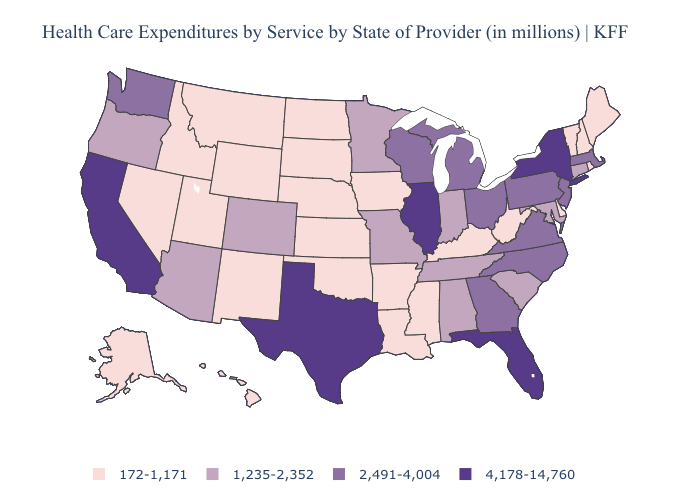Does Arizona have a lower value than Massachusetts?
Keep it brief. Yes. Name the states that have a value in the range 4,178-14,760?
Answer briefly. California, Florida, Illinois, New York, Texas. Name the states that have a value in the range 1,235-2,352?
Quick response, please. Alabama, Arizona, Colorado, Connecticut, Indiana, Maryland, Minnesota, Missouri, Oregon, South Carolina, Tennessee. Which states have the highest value in the USA?
Quick response, please. California, Florida, Illinois, New York, Texas. What is the lowest value in the Northeast?
Quick response, please. 172-1,171. Name the states that have a value in the range 2,491-4,004?
Be succinct. Georgia, Massachusetts, Michigan, New Jersey, North Carolina, Ohio, Pennsylvania, Virginia, Washington, Wisconsin. Which states have the highest value in the USA?
Quick response, please. California, Florida, Illinois, New York, Texas. What is the value of Tennessee?
Be succinct. 1,235-2,352. Among the states that border Pennsylvania , which have the highest value?
Be succinct. New York. How many symbols are there in the legend?
Write a very short answer. 4. What is the value of California?
Give a very brief answer. 4,178-14,760. Name the states that have a value in the range 172-1,171?
Concise answer only. Alaska, Arkansas, Delaware, Hawaii, Idaho, Iowa, Kansas, Kentucky, Louisiana, Maine, Mississippi, Montana, Nebraska, Nevada, New Hampshire, New Mexico, North Dakota, Oklahoma, Rhode Island, South Dakota, Utah, Vermont, West Virginia, Wyoming. Does Massachusetts have the highest value in the USA?
Write a very short answer. No. What is the value of Washington?
Give a very brief answer. 2,491-4,004. What is the value of New Mexico?
Keep it brief. 172-1,171. 